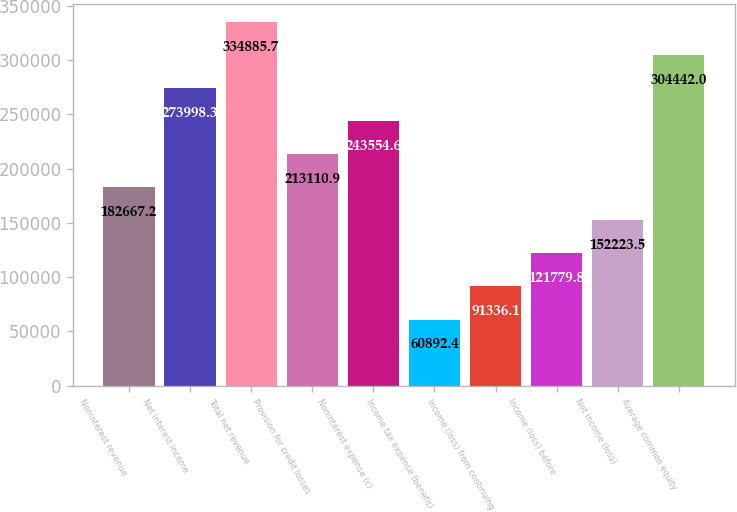Convert chart to OTSL. <chart><loc_0><loc_0><loc_500><loc_500><bar_chart><fcel>Noninterest revenue<fcel>Net interest income<fcel>Total net revenue<fcel>Provision for credit losses<fcel>Noninterest expense (c)<fcel>Income tax expense (benefit)<fcel>Income (loss) from continuing<fcel>Income (loss) before<fcel>Net income (loss)<fcel>Average common equity<nl><fcel>182667<fcel>273998<fcel>334886<fcel>213111<fcel>243555<fcel>60892.4<fcel>91336.1<fcel>121780<fcel>152224<fcel>304442<nl></chart> 